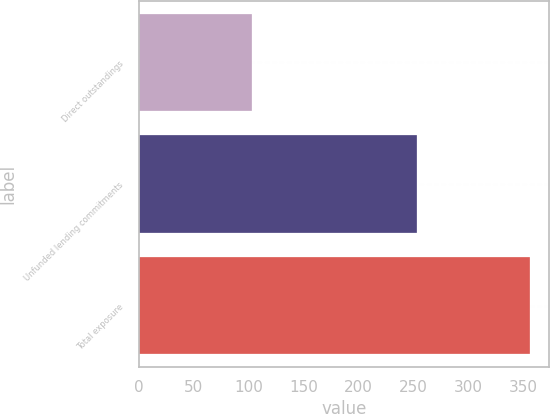<chart> <loc_0><loc_0><loc_500><loc_500><bar_chart><fcel>Direct outstandings<fcel>Unfunded lending commitments<fcel>Total exposure<nl><fcel>103<fcel>253<fcel>356<nl></chart> 